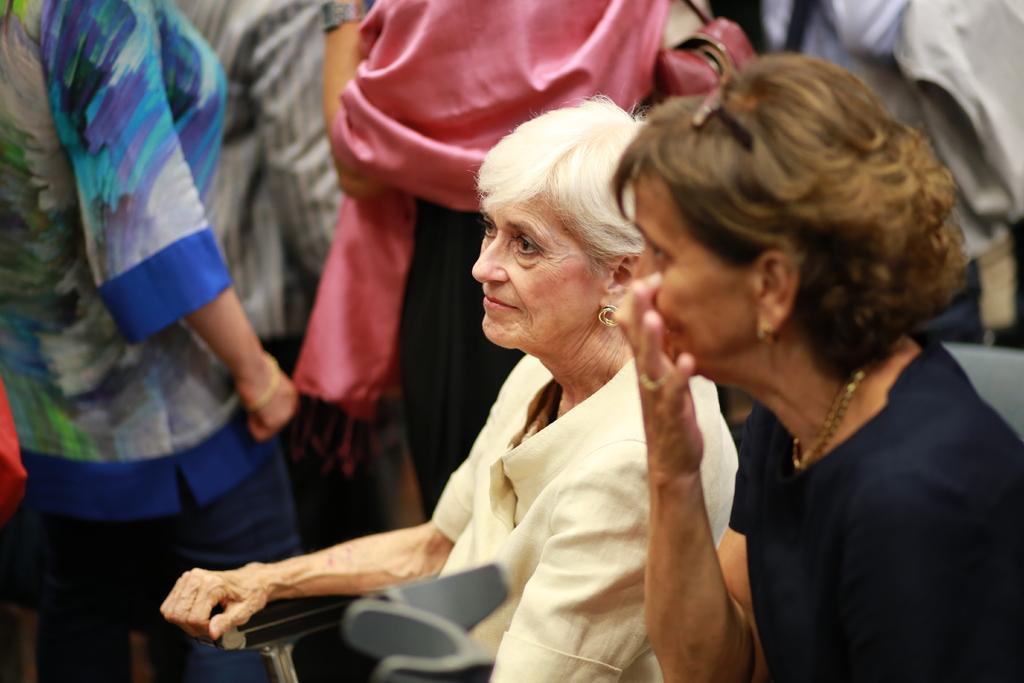How would you summarize this image in a sentence or two? In this image we can see few people, some of them are standing and two of them are sitting on the chairs. 